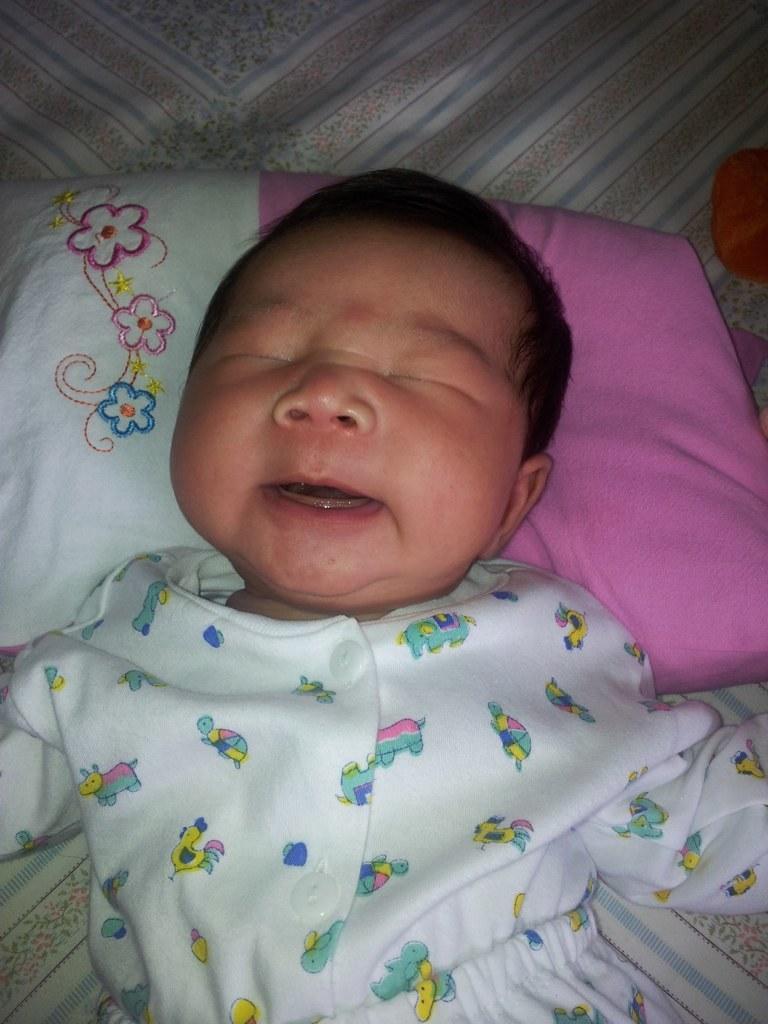In one or two sentences, can you explain what this image depicts? In this image, I can see a small baby lying on the bed. This looks like a pillow. I think this is a bed sheet. 